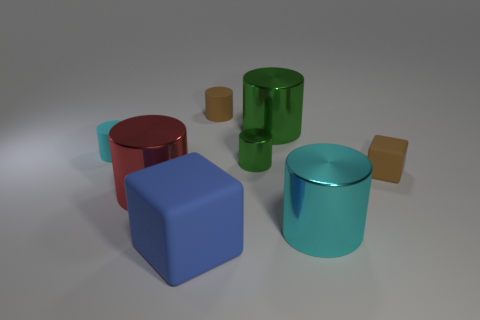How many cyan cylinders must be subtracted to get 1 cyan cylinders? 1 Subtract all cyan spheres. How many cyan cylinders are left? 2 Subtract all small brown rubber cylinders. How many cylinders are left? 5 Subtract all brown cylinders. How many cylinders are left? 5 Subtract 4 cylinders. How many cylinders are left? 2 Add 2 green objects. How many objects exist? 10 Subtract all green cylinders. Subtract all red balls. How many cylinders are left? 4 Subtract all cubes. How many objects are left? 6 Subtract all big green cylinders. Subtract all shiny objects. How many objects are left? 3 Add 4 large blue matte objects. How many large blue matte objects are left? 5 